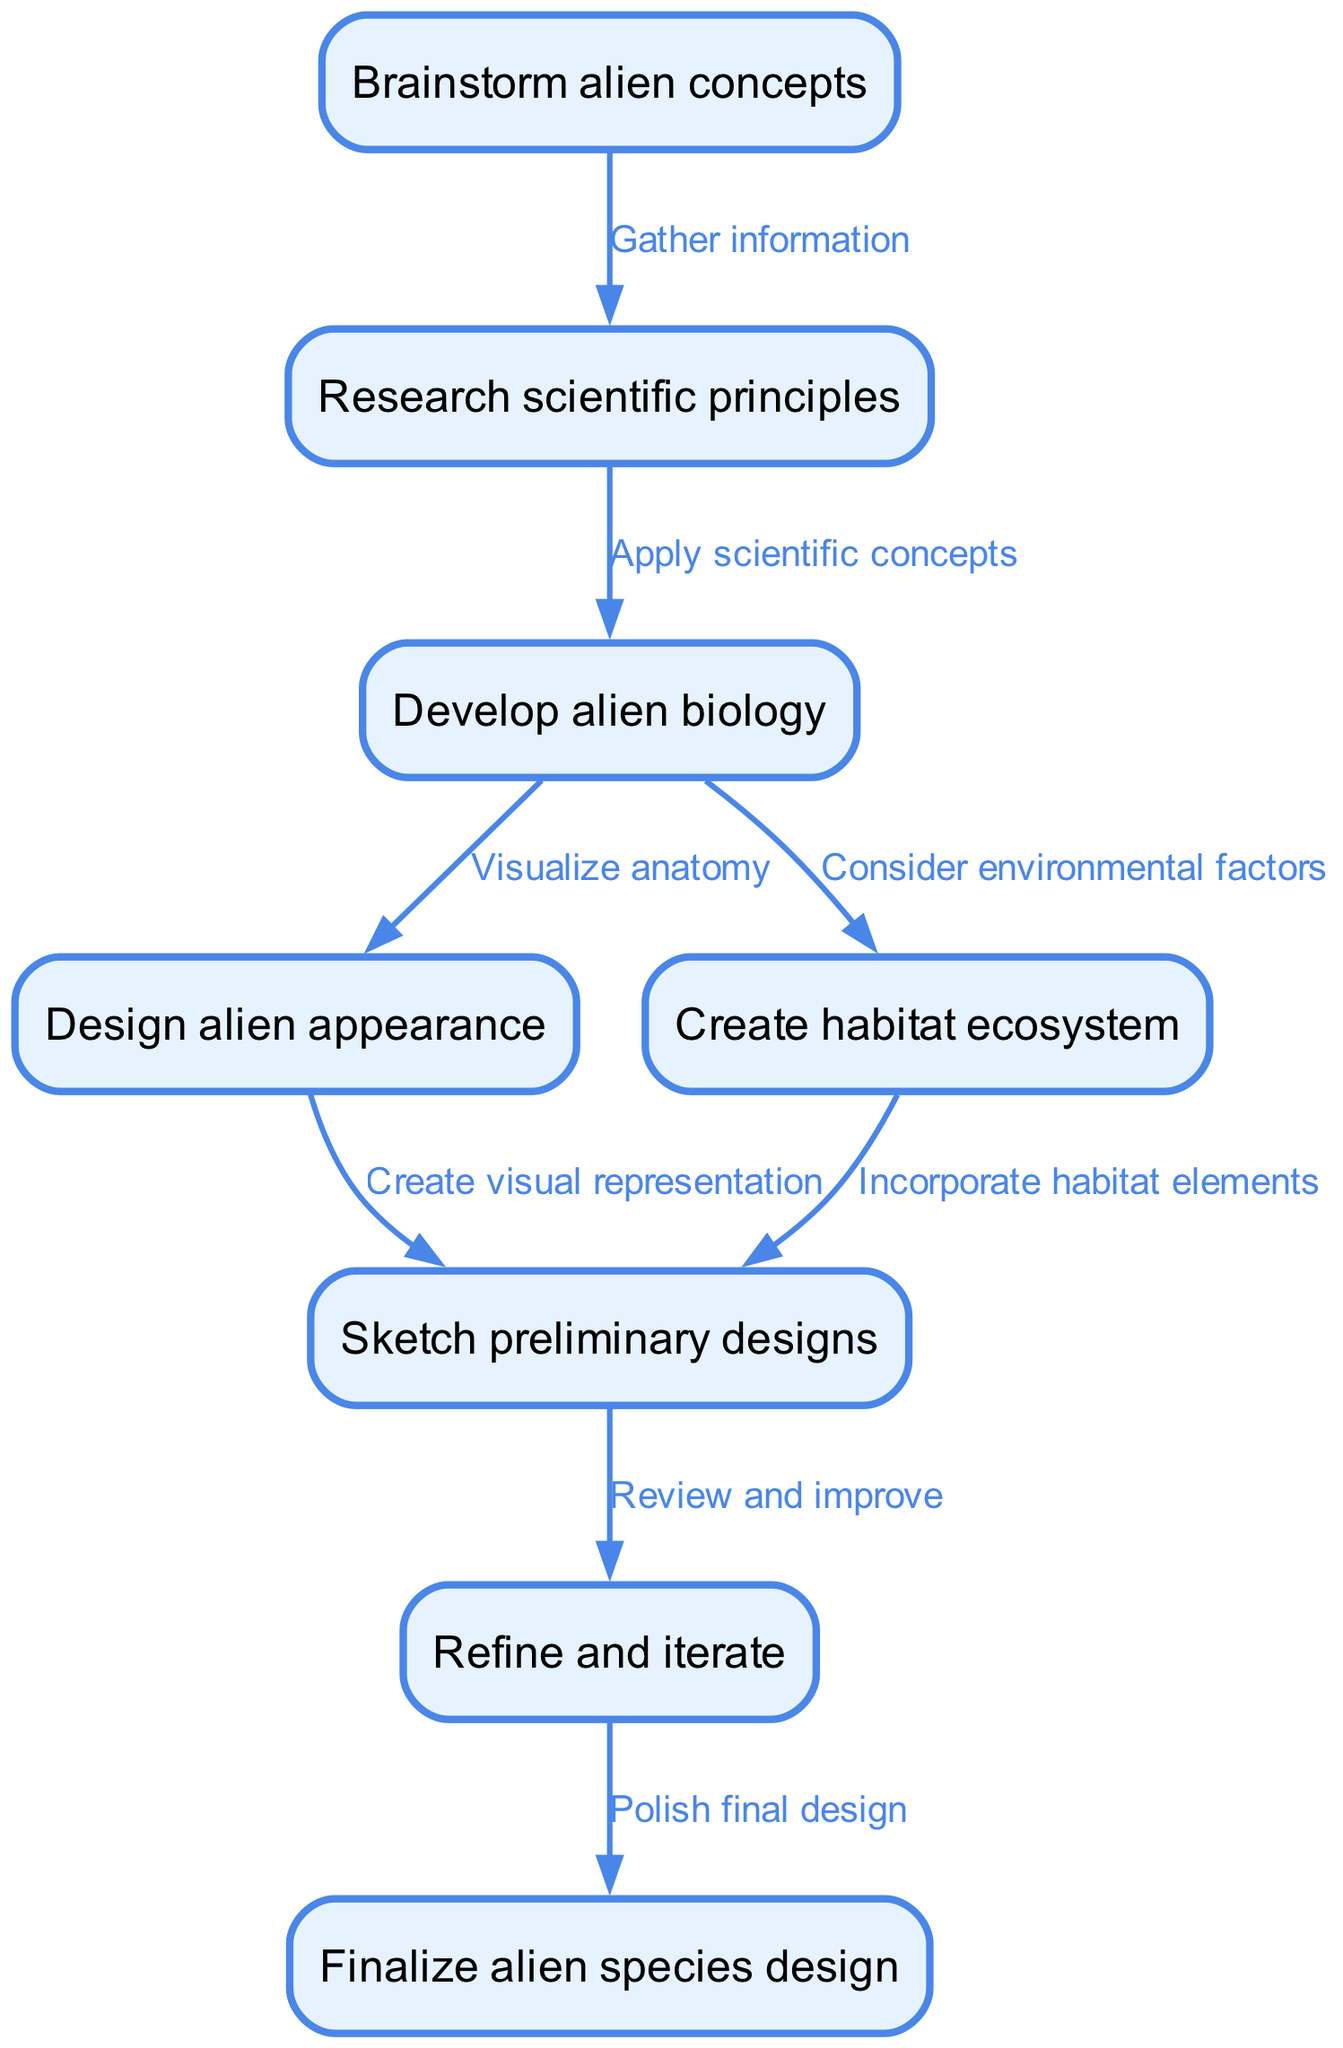What is the first step in the alien species creation process? The first node in the flow chart indicates "Brainstorm alien concepts" as the initial step to start the process of creating an alien species.
Answer: Brainstorm alien concepts How many major nodes are there in the diagram? By counting the nodes listed in the flow chart, it is observed that there are a total of eight distinct nodes representing different steps in the alien species creation process.
Answer: Eight What step follows "Research scientific principles"? Examining the flow from the node "Research scientific principles" leads to the node labeled "Develop alien biology," which is the next step in the sequence.
Answer: Develop alien biology Which two nodes are involved in the visual representation of the alien? The nodes "Design alien appearance" and "Sketch preliminary designs" are directly connected, indicating that designing appearance involves creating visual representations through preliminary sketches.
Answer: Design alien appearance, Sketch preliminary designs What is the final step in the process? The last node in the flow chart denotes "Finalize alien species design," marking it as the concluding step in the creation process for an alien species.
Answer: Finalize alien species design Which step considers environmental factors? Observing the connections, the step "Consider environmental factors" is linked to the node for developing alien biology, which suggests this consideration occurs in that process.
Answer: Consider environmental factors What connects "Sketch preliminary designs" and "Refine and iterate"? Following the directed edge from "Sketch preliminary designs" to "Refine and iterate," it shows that the refinement process is a logical next step after creating preliminary designs.
Answer: Review and improve Which steps are directly related to habitat? The connections reveal "Create habitat ecosystem" and "Incorporate habitat elements" as the relevant nodes directly tied to the habitat aspect of alien species creation.
Answer: Create habitat ecosystem, Incorporate habitat elements 